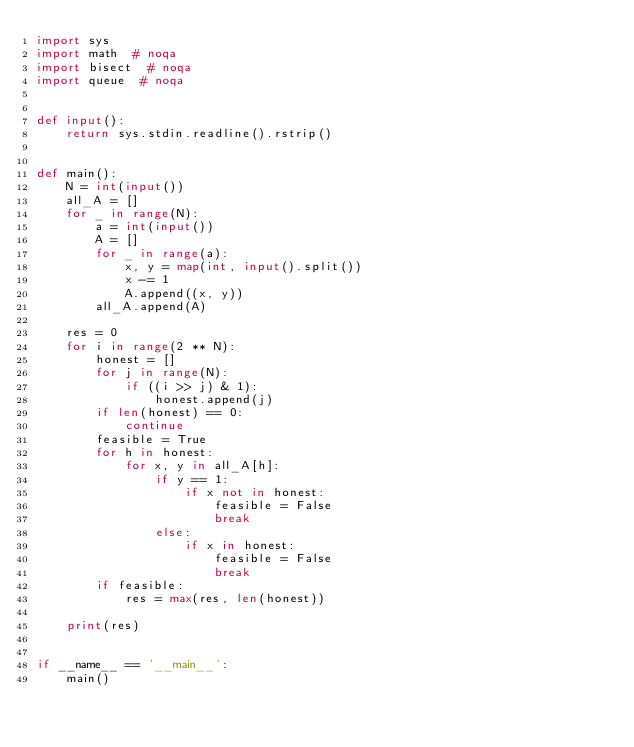<code> <loc_0><loc_0><loc_500><loc_500><_Python_>import sys
import math  # noqa
import bisect  # noqa
import queue  # noqa


def input():
    return sys.stdin.readline().rstrip()


def main():
    N = int(input())
    all_A = []
    for _ in range(N):
        a = int(input())
        A = []
        for _ in range(a):
            x, y = map(int, input().split())
            x -= 1
            A.append((x, y))
        all_A.append(A)

    res = 0
    for i in range(2 ** N):
        honest = []
        for j in range(N):
            if ((i >> j) & 1):
                honest.append(j)
        if len(honest) == 0:
            continue
        feasible = True
        for h in honest:
            for x, y in all_A[h]:
                if y == 1:
                    if x not in honest:
                        feasible = False
                        break
                else:
                    if x in honest:
                        feasible = False
                        break
        if feasible:
            res = max(res, len(honest))

    print(res)


if __name__ == '__main__':
    main()
</code> 